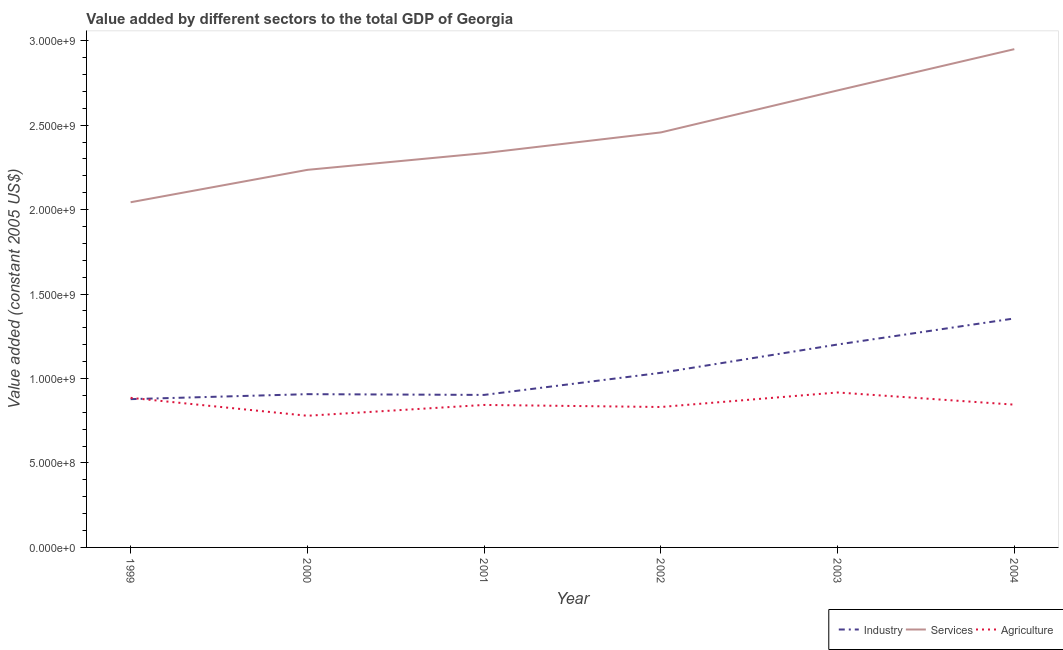How many different coloured lines are there?
Your answer should be very brief. 3. Does the line corresponding to value added by services intersect with the line corresponding to value added by industrial sector?
Offer a very short reply. No. Is the number of lines equal to the number of legend labels?
Provide a succinct answer. Yes. What is the value added by services in 2003?
Ensure brevity in your answer.  2.71e+09. Across all years, what is the maximum value added by services?
Keep it short and to the point. 2.95e+09. Across all years, what is the minimum value added by industrial sector?
Offer a very short reply. 8.78e+08. In which year was the value added by services maximum?
Provide a short and direct response. 2004. What is the total value added by industrial sector in the graph?
Keep it short and to the point. 6.28e+09. What is the difference between the value added by industrial sector in 2001 and that in 2004?
Offer a terse response. -4.53e+08. What is the difference between the value added by industrial sector in 1999 and the value added by agricultural sector in 2004?
Keep it short and to the point. 3.27e+07. What is the average value added by services per year?
Give a very brief answer. 2.45e+09. In the year 2003, what is the difference between the value added by industrial sector and value added by services?
Your response must be concise. -1.50e+09. What is the ratio of the value added by industrial sector in 2001 to that in 2004?
Ensure brevity in your answer.  0.67. What is the difference between the highest and the second highest value added by industrial sector?
Your answer should be very brief. 1.54e+08. What is the difference between the highest and the lowest value added by services?
Your answer should be compact. 9.06e+08. In how many years, is the value added by services greater than the average value added by services taken over all years?
Offer a terse response. 3. Is the sum of the value added by industrial sector in 2001 and 2003 greater than the maximum value added by agricultural sector across all years?
Provide a short and direct response. Yes. Is it the case that in every year, the sum of the value added by industrial sector and value added by services is greater than the value added by agricultural sector?
Offer a very short reply. Yes. Is the value added by agricultural sector strictly less than the value added by services over the years?
Offer a terse response. Yes. How many lines are there?
Give a very brief answer. 3. What is the difference between two consecutive major ticks on the Y-axis?
Give a very brief answer. 5.00e+08. Does the graph contain grids?
Offer a terse response. No. Where does the legend appear in the graph?
Provide a short and direct response. Bottom right. What is the title of the graph?
Offer a very short reply. Value added by different sectors to the total GDP of Georgia. Does "Manufactures" appear as one of the legend labels in the graph?
Ensure brevity in your answer.  No. What is the label or title of the Y-axis?
Ensure brevity in your answer.  Value added (constant 2005 US$). What is the Value added (constant 2005 US$) in Industry in 1999?
Offer a very short reply. 8.78e+08. What is the Value added (constant 2005 US$) of Services in 1999?
Keep it short and to the point. 2.04e+09. What is the Value added (constant 2005 US$) of Agriculture in 1999?
Keep it short and to the point. 8.86e+08. What is the Value added (constant 2005 US$) of Industry in 2000?
Make the answer very short. 9.07e+08. What is the Value added (constant 2005 US$) in Services in 2000?
Ensure brevity in your answer.  2.24e+09. What is the Value added (constant 2005 US$) of Agriculture in 2000?
Keep it short and to the point. 7.80e+08. What is the Value added (constant 2005 US$) of Industry in 2001?
Provide a short and direct response. 9.03e+08. What is the Value added (constant 2005 US$) of Services in 2001?
Offer a terse response. 2.33e+09. What is the Value added (constant 2005 US$) of Agriculture in 2001?
Give a very brief answer. 8.44e+08. What is the Value added (constant 2005 US$) in Industry in 2002?
Provide a succinct answer. 1.03e+09. What is the Value added (constant 2005 US$) of Services in 2002?
Offer a terse response. 2.46e+09. What is the Value added (constant 2005 US$) of Agriculture in 2002?
Keep it short and to the point. 8.31e+08. What is the Value added (constant 2005 US$) in Industry in 2003?
Ensure brevity in your answer.  1.20e+09. What is the Value added (constant 2005 US$) of Services in 2003?
Offer a terse response. 2.71e+09. What is the Value added (constant 2005 US$) of Agriculture in 2003?
Keep it short and to the point. 9.17e+08. What is the Value added (constant 2005 US$) of Industry in 2004?
Your answer should be very brief. 1.36e+09. What is the Value added (constant 2005 US$) of Services in 2004?
Offer a very short reply. 2.95e+09. What is the Value added (constant 2005 US$) of Agriculture in 2004?
Ensure brevity in your answer.  8.45e+08. Across all years, what is the maximum Value added (constant 2005 US$) of Industry?
Offer a terse response. 1.36e+09. Across all years, what is the maximum Value added (constant 2005 US$) in Services?
Your response must be concise. 2.95e+09. Across all years, what is the maximum Value added (constant 2005 US$) of Agriculture?
Provide a short and direct response. 9.17e+08. Across all years, what is the minimum Value added (constant 2005 US$) of Industry?
Offer a very short reply. 8.78e+08. Across all years, what is the minimum Value added (constant 2005 US$) in Services?
Keep it short and to the point. 2.04e+09. Across all years, what is the minimum Value added (constant 2005 US$) of Agriculture?
Your response must be concise. 7.80e+08. What is the total Value added (constant 2005 US$) of Industry in the graph?
Your response must be concise. 6.28e+09. What is the total Value added (constant 2005 US$) of Services in the graph?
Keep it short and to the point. 1.47e+1. What is the total Value added (constant 2005 US$) of Agriculture in the graph?
Keep it short and to the point. 5.10e+09. What is the difference between the Value added (constant 2005 US$) of Industry in 1999 and that in 2000?
Provide a short and direct response. -2.95e+07. What is the difference between the Value added (constant 2005 US$) in Services in 1999 and that in 2000?
Provide a short and direct response. -1.92e+08. What is the difference between the Value added (constant 2005 US$) in Agriculture in 1999 and that in 2000?
Offer a very short reply. 1.06e+08. What is the difference between the Value added (constant 2005 US$) of Industry in 1999 and that in 2001?
Make the answer very short. -2.50e+07. What is the difference between the Value added (constant 2005 US$) in Services in 1999 and that in 2001?
Provide a short and direct response. -2.91e+08. What is the difference between the Value added (constant 2005 US$) in Agriculture in 1999 and that in 2001?
Your response must be concise. 4.20e+07. What is the difference between the Value added (constant 2005 US$) of Industry in 1999 and that in 2002?
Offer a very short reply. -1.56e+08. What is the difference between the Value added (constant 2005 US$) in Services in 1999 and that in 2002?
Provide a succinct answer. -4.13e+08. What is the difference between the Value added (constant 2005 US$) in Agriculture in 1999 and that in 2002?
Offer a terse response. 5.42e+07. What is the difference between the Value added (constant 2005 US$) in Industry in 1999 and that in 2003?
Make the answer very short. -3.23e+08. What is the difference between the Value added (constant 2005 US$) of Services in 1999 and that in 2003?
Offer a terse response. -6.62e+08. What is the difference between the Value added (constant 2005 US$) of Agriculture in 1999 and that in 2003?
Offer a terse response. -3.18e+07. What is the difference between the Value added (constant 2005 US$) of Industry in 1999 and that in 2004?
Ensure brevity in your answer.  -4.78e+08. What is the difference between the Value added (constant 2005 US$) in Services in 1999 and that in 2004?
Give a very brief answer. -9.06e+08. What is the difference between the Value added (constant 2005 US$) of Agriculture in 1999 and that in 2004?
Your response must be concise. 4.04e+07. What is the difference between the Value added (constant 2005 US$) in Industry in 2000 and that in 2001?
Provide a short and direct response. 4.43e+06. What is the difference between the Value added (constant 2005 US$) in Services in 2000 and that in 2001?
Offer a terse response. -9.90e+07. What is the difference between the Value added (constant 2005 US$) in Agriculture in 2000 and that in 2001?
Provide a short and direct response. -6.40e+07. What is the difference between the Value added (constant 2005 US$) of Industry in 2000 and that in 2002?
Give a very brief answer. -1.26e+08. What is the difference between the Value added (constant 2005 US$) of Services in 2000 and that in 2002?
Offer a terse response. -2.22e+08. What is the difference between the Value added (constant 2005 US$) of Agriculture in 2000 and that in 2002?
Provide a short and direct response. -5.19e+07. What is the difference between the Value added (constant 2005 US$) in Industry in 2000 and that in 2003?
Your response must be concise. -2.94e+08. What is the difference between the Value added (constant 2005 US$) of Services in 2000 and that in 2003?
Provide a succinct answer. -4.70e+08. What is the difference between the Value added (constant 2005 US$) in Agriculture in 2000 and that in 2003?
Provide a short and direct response. -1.38e+08. What is the difference between the Value added (constant 2005 US$) in Industry in 2000 and that in 2004?
Provide a short and direct response. -4.48e+08. What is the difference between the Value added (constant 2005 US$) of Services in 2000 and that in 2004?
Your response must be concise. -7.15e+08. What is the difference between the Value added (constant 2005 US$) of Agriculture in 2000 and that in 2004?
Offer a very short reply. -6.57e+07. What is the difference between the Value added (constant 2005 US$) of Industry in 2001 and that in 2002?
Ensure brevity in your answer.  -1.31e+08. What is the difference between the Value added (constant 2005 US$) of Services in 2001 and that in 2002?
Ensure brevity in your answer.  -1.23e+08. What is the difference between the Value added (constant 2005 US$) of Agriculture in 2001 and that in 2002?
Your response must be concise. 1.22e+07. What is the difference between the Value added (constant 2005 US$) of Industry in 2001 and that in 2003?
Your answer should be compact. -2.98e+08. What is the difference between the Value added (constant 2005 US$) of Services in 2001 and that in 2003?
Your answer should be compact. -3.71e+08. What is the difference between the Value added (constant 2005 US$) of Agriculture in 2001 and that in 2003?
Provide a short and direct response. -7.38e+07. What is the difference between the Value added (constant 2005 US$) of Industry in 2001 and that in 2004?
Provide a short and direct response. -4.53e+08. What is the difference between the Value added (constant 2005 US$) of Services in 2001 and that in 2004?
Offer a very short reply. -6.16e+08. What is the difference between the Value added (constant 2005 US$) in Agriculture in 2001 and that in 2004?
Provide a succinct answer. -1.68e+06. What is the difference between the Value added (constant 2005 US$) in Industry in 2002 and that in 2003?
Offer a terse response. -1.68e+08. What is the difference between the Value added (constant 2005 US$) of Services in 2002 and that in 2003?
Offer a very short reply. -2.49e+08. What is the difference between the Value added (constant 2005 US$) in Agriculture in 2002 and that in 2003?
Offer a very short reply. -8.60e+07. What is the difference between the Value added (constant 2005 US$) of Industry in 2002 and that in 2004?
Provide a short and direct response. -3.22e+08. What is the difference between the Value added (constant 2005 US$) of Services in 2002 and that in 2004?
Give a very brief answer. -4.93e+08. What is the difference between the Value added (constant 2005 US$) of Agriculture in 2002 and that in 2004?
Offer a terse response. -1.39e+07. What is the difference between the Value added (constant 2005 US$) of Industry in 2003 and that in 2004?
Offer a very short reply. -1.54e+08. What is the difference between the Value added (constant 2005 US$) in Services in 2003 and that in 2004?
Your answer should be compact. -2.44e+08. What is the difference between the Value added (constant 2005 US$) of Agriculture in 2003 and that in 2004?
Ensure brevity in your answer.  7.21e+07. What is the difference between the Value added (constant 2005 US$) in Industry in 1999 and the Value added (constant 2005 US$) in Services in 2000?
Your answer should be compact. -1.36e+09. What is the difference between the Value added (constant 2005 US$) of Industry in 1999 and the Value added (constant 2005 US$) of Agriculture in 2000?
Offer a terse response. 9.84e+07. What is the difference between the Value added (constant 2005 US$) in Services in 1999 and the Value added (constant 2005 US$) in Agriculture in 2000?
Keep it short and to the point. 1.26e+09. What is the difference between the Value added (constant 2005 US$) in Industry in 1999 and the Value added (constant 2005 US$) in Services in 2001?
Provide a succinct answer. -1.46e+09. What is the difference between the Value added (constant 2005 US$) of Industry in 1999 and the Value added (constant 2005 US$) of Agriculture in 2001?
Offer a very short reply. 3.43e+07. What is the difference between the Value added (constant 2005 US$) in Services in 1999 and the Value added (constant 2005 US$) in Agriculture in 2001?
Your answer should be very brief. 1.20e+09. What is the difference between the Value added (constant 2005 US$) in Industry in 1999 and the Value added (constant 2005 US$) in Services in 2002?
Keep it short and to the point. -1.58e+09. What is the difference between the Value added (constant 2005 US$) in Industry in 1999 and the Value added (constant 2005 US$) in Agriculture in 2002?
Your answer should be very brief. 4.65e+07. What is the difference between the Value added (constant 2005 US$) of Services in 1999 and the Value added (constant 2005 US$) of Agriculture in 2002?
Keep it short and to the point. 1.21e+09. What is the difference between the Value added (constant 2005 US$) in Industry in 1999 and the Value added (constant 2005 US$) in Services in 2003?
Provide a succinct answer. -1.83e+09. What is the difference between the Value added (constant 2005 US$) in Industry in 1999 and the Value added (constant 2005 US$) in Agriculture in 2003?
Offer a very short reply. -3.95e+07. What is the difference between the Value added (constant 2005 US$) of Services in 1999 and the Value added (constant 2005 US$) of Agriculture in 2003?
Provide a succinct answer. 1.13e+09. What is the difference between the Value added (constant 2005 US$) of Industry in 1999 and the Value added (constant 2005 US$) of Services in 2004?
Offer a terse response. -2.07e+09. What is the difference between the Value added (constant 2005 US$) in Industry in 1999 and the Value added (constant 2005 US$) in Agriculture in 2004?
Your response must be concise. 3.27e+07. What is the difference between the Value added (constant 2005 US$) in Services in 1999 and the Value added (constant 2005 US$) in Agriculture in 2004?
Your answer should be compact. 1.20e+09. What is the difference between the Value added (constant 2005 US$) of Industry in 2000 and the Value added (constant 2005 US$) of Services in 2001?
Your answer should be very brief. -1.43e+09. What is the difference between the Value added (constant 2005 US$) of Industry in 2000 and the Value added (constant 2005 US$) of Agriculture in 2001?
Your response must be concise. 6.38e+07. What is the difference between the Value added (constant 2005 US$) of Services in 2000 and the Value added (constant 2005 US$) of Agriculture in 2001?
Offer a very short reply. 1.39e+09. What is the difference between the Value added (constant 2005 US$) in Industry in 2000 and the Value added (constant 2005 US$) in Services in 2002?
Offer a terse response. -1.55e+09. What is the difference between the Value added (constant 2005 US$) in Industry in 2000 and the Value added (constant 2005 US$) in Agriculture in 2002?
Your answer should be compact. 7.60e+07. What is the difference between the Value added (constant 2005 US$) in Services in 2000 and the Value added (constant 2005 US$) in Agriculture in 2002?
Keep it short and to the point. 1.40e+09. What is the difference between the Value added (constant 2005 US$) in Industry in 2000 and the Value added (constant 2005 US$) in Services in 2003?
Keep it short and to the point. -1.80e+09. What is the difference between the Value added (constant 2005 US$) of Industry in 2000 and the Value added (constant 2005 US$) of Agriculture in 2003?
Offer a terse response. -1.00e+07. What is the difference between the Value added (constant 2005 US$) of Services in 2000 and the Value added (constant 2005 US$) of Agriculture in 2003?
Your answer should be very brief. 1.32e+09. What is the difference between the Value added (constant 2005 US$) of Industry in 2000 and the Value added (constant 2005 US$) of Services in 2004?
Provide a succinct answer. -2.04e+09. What is the difference between the Value added (constant 2005 US$) of Industry in 2000 and the Value added (constant 2005 US$) of Agriculture in 2004?
Offer a terse response. 6.21e+07. What is the difference between the Value added (constant 2005 US$) of Services in 2000 and the Value added (constant 2005 US$) of Agriculture in 2004?
Offer a terse response. 1.39e+09. What is the difference between the Value added (constant 2005 US$) of Industry in 2001 and the Value added (constant 2005 US$) of Services in 2002?
Your answer should be compact. -1.55e+09. What is the difference between the Value added (constant 2005 US$) in Industry in 2001 and the Value added (constant 2005 US$) in Agriculture in 2002?
Offer a very short reply. 7.16e+07. What is the difference between the Value added (constant 2005 US$) of Services in 2001 and the Value added (constant 2005 US$) of Agriculture in 2002?
Offer a very short reply. 1.50e+09. What is the difference between the Value added (constant 2005 US$) of Industry in 2001 and the Value added (constant 2005 US$) of Services in 2003?
Offer a terse response. -1.80e+09. What is the difference between the Value added (constant 2005 US$) of Industry in 2001 and the Value added (constant 2005 US$) of Agriculture in 2003?
Provide a short and direct response. -1.44e+07. What is the difference between the Value added (constant 2005 US$) in Services in 2001 and the Value added (constant 2005 US$) in Agriculture in 2003?
Offer a very short reply. 1.42e+09. What is the difference between the Value added (constant 2005 US$) in Industry in 2001 and the Value added (constant 2005 US$) in Services in 2004?
Your answer should be compact. -2.05e+09. What is the difference between the Value added (constant 2005 US$) of Industry in 2001 and the Value added (constant 2005 US$) of Agriculture in 2004?
Your answer should be very brief. 5.77e+07. What is the difference between the Value added (constant 2005 US$) of Services in 2001 and the Value added (constant 2005 US$) of Agriculture in 2004?
Provide a succinct answer. 1.49e+09. What is the difference between the Value added (constant 2005 US$) of Industry in 2002 and the Value added (constant 2005 US$) of Services in 2003?
Your response must be concise. -1.67e+09. What is the difference between the Value added (constant 2005 US$) of Industry in 2002 and the Value added (constant 2005 US$) of Agriculture in 2003?
Your answer should be very brief. 1.16e+08. What is the difference between the Value added (constant 2005 US$) of Services in 2002 and the Value added (constant 2005 US$) of Agriculture in 2003?
Offer a very short reply. 1.54e+09. What is the difference between the Value added (constant 2005 US$) in Industry in 2002 and the Value added (constant 2005 US$) in Services in 2004?
Give a very brief answer. -1.92e+09. What is the difference between the Value added (constant 2005 US$) in Industry in 2002 and the Value added (constant 2005 US$) in Agriculture in 2004?
Your answer should be compact. 1.88e+08. What is the difference between the Value added (constant 2005 US$) in Services in 2002 and the Value added (constant 2005 US$) in Agriculture in 2004?
Make the answer very short. 1.61e+09. What is the difference between the Value added (constant 2005 US$) in Industry in 2003 and the Value added (constant 2005 US$) in Services in 2004?
Provide a succinct answer. -1.75e+09. What is the difference between the Value added (constant 2005 US$) in Industry in 2003 and the Value added (constant 2005 US$) in Agriculture in 2004?
Give a very brief answer. 3.56e+08. What is the difference between the Value added (constant 2005 US$) of Services in 2003 and the Value added (constant 2005 US$) of Agriculture in 2004?
Your answer should be compact. 1.86e+09. What is the average Value added (constant 2005 US$) in Industry per year?
Keep it short and to the point. 1.05e+09. What is the average Value added (constant 2005 US$) in Services per year?
Offer a very short reply. 2.45e+09. What is the average Value added (constant 2005 US$) in Agriculture per year?
Offer a very short reply. 8.51e+08. In the year 1999, what is the difference between the Value added (constant 2005 US$) of Industry and Value added (constant 2005 US$) of Services?
Provide a short and direct response. -1.17e+09. In the year 1999, what is the difference between the Value added (constant 2005 US$) in Industry and Value added (constant 2005 US$) in Agriculture?
Make the answer very short. -7.70e+06. In the year 1999, what is the difference between the Value added (constant 2005 US$) in Services and Value added (constant 2005 US$) in Agriculture?
Make the answer very short. 1.16e+09. In the year 2000, what is the difference between the Value added (constant 2005 US$) of Industry and Value added (constant 2005 US$) of Services?
Keep it short and to the point. -1.33e+09. In the year 2000, what is the difference between the Value added (constant 2005 US$) of Industry and Value added (constant 2005 US$) of Agriculture?
Keep it short and to the point. 1.28e+08. In the year 2000, what is the difference between the Value added (constant 2005 US$) in Services and Value added (constant 2005 US$) in Agriculture?
Provide a short and direct response. 1.46e+09. In the year 2001, what is the difference between the Value added (constant 2005 US$) in Industry and Value added (constant 2005 US$) in Services?
Ensure brevity in your answer.  -1.43e+09. In the year 2001, what is the difference between the Value added (constant 2005 US$) in Industry and Value added (constant 2005 US$) in Agriculture?
Your response must be concise. 5.94e+07. In the year 2001, what is the difference between the Value added (constant 2005 US$) of Services and Value added (constant 2005 US$) of Agriculture?
Keep it short and to the point. 1.49e+09. In the year 2002, what is the difference between the Value added (constant 2005 US$) of Industry and Value added (constant 2005 US$) of Services?
Provide a succinct answer. -1.42e+09. In the year 2002, what is the difference between the Value added (constant 2005 US$) in Industry and Value added (constant 2005 US$) in Agriculture?
Provide a succinct answer. 2.02e+08. In the year 2002, what is the difference between the Value added (constant 2005 US$) of Services and Value added (constant 2005 US$) of Agriculture?
Your answer should be very brief. 1.63e+09. In the year 2003, what is the difference between the Value added (constant 2005 US$) of Industry and Value added (constant 2005 US$) of Services?
Offer a terse response. -1.50e+09. In the year 2003, what is the difference between the Value added (constant 2005 US$) in Industry and Value added (constant 2005 US$) in Agriculture?
Offer a very short reply. 2.84e+08. In the year 2003, what is the difference between the Value added (constant 2005 US$) in Services and Value added (constant 2005 US$) in Agriculture?
Offer a very short reply. 1.79e+09. In the year 2004, what is the difference between the Value added (constant 2005 US$) in Industry and Value added (constant 2005 US$) in Services?
Make the answer very short. -1.59e+09. In the year 2004, what is the difference between the Value added (constant 2005 US$) of Industry and Value added (constant 2005 US$) of Agriculture?
Your answer should be compact. 5.10e+08. In the year 2004, what is the difference between the Value added (constant 2005 US$) of Services and Value added (constant 2005 US$) of Agriculture?
Ensure brevity in your answer.  2.10e+09. What is the ratio of the Value added (constant 2005 US$) of Industry in 1999 to that in 2000?
Your answer should be compact. 0.97. What is the ratio of the Value added (constant 2005 US$) of Services in 1999 to that in 2000?
Your answer should be compact. 0.91. What is the ratio of the Value added (constant 2005 US$) of Agriculture in 1999 to that in 2000?
Your answer should be compact. 1.14. What is the ratio of the Value added (constant 2005 US$) in Industry in 1999 to that in 2001?
Keep it short and to the point. 0.97. What is the ratio of the Value added (constant 2005 US$) in Services in 1999 to that in 2001?
Provide a short and direct response. 0.88. What is the ratio of the Value added (constant 2005 US$) in Agriculture in 1999 to that in 2001?
Your response must be concise. 1.05. What is the ratio of the Value added (constant 2005 US$) of Industry in 1999 to that in 2002?
Ensure brevity in your answer.  0.85. What is the ratio of the Value added (constant 2005 US$) in Services in 1999 to that in 2002?
Your answer should be very brief. 0.83. What is the ratio of the Value added (constant 2005 US$) of Agriculture in 1999 to that in 2002?
Your answer should be very brief. 1.07. What is the ratio of the Value added (constant 2005 US$) of Industry in 1999 to that in 2003?
Provide a succinct answer. 0.73. What is the ratio of the Value added (constant 2005 US$) of Services in 1999 to that in 2003?
Keep it short and to the point. 0.76. What is the ratio of the Value added (constant 2005 US$) in Agriculture in 1999 to that in 2003?
Your response must be concise. 0.97. What is the ratio of the Value added (constant 2005 US$) of Industry in 1999 to that in 2004?
Offer a terse response. 0.65. What is the ratio of the Value added (constant 2005 US$) of Services in 1999 to that in 2004?
Keep it short and to the point. 0.69. What is the ratio of the Value added (constant 2005 US$) of Agriculture in 1999 to that in 2004?
Offer a very short reply. 1.05. What is the ratio of the Value added (constant 2005 US$) of Services in 2000 to that in 2001?
Ensure brevity in your answer.  0.96. What is the ratio of the Value added (constant 2005 US$) in Agriculture in 2000 to that in 2001?
Your answer should be very brief. 0.92. What is the ratio of the Value added (constant 2005 US$) in Industry in 2000 to that in 2002?
Offer a very short reply. 0.88. What is the ratio of the Value added (constant 2005 US$) of Services in 2000 to that in 2002?
Offer a terse response. 0.91. What is the ratio of the Value added (constant 2005 US$) of Agriculture in 2000 to that in 2002?
Your answer should be compact. 0.94. What is the ratio of the Value added (constant 2005 US$) in Industry in 2000 to that in 2003?
Your answer should be compact. 0.76. What is the ratio of the Value added (constant 2005 US$) in Services in 2000 to that in 2003?
Your answer should be very brief. 0.83. What is the ratio of the Value added (constant 2005 US$) in Agriculture in 2000 to that in 2003?
Keep it short and to the point. 0.85. What is the ratio of the Value added (constant 2005 US$) of Industry in 2000 to that in 2004?
Offer a terse response. 0.67. What is the ratio of the Value added (constant 2005 US$) in Services in 2000 to that in 2004?
Provide a succinct answer. 0.76. What is the ratio of the Value added (constant 2005 US$) of Agriculture in 2000 to that in 2004?
Provide a succinct answer. 0.92. What is the ratio of the Value added (constant 2005 US$) of Industry in 2001 to that in 2002?
Give a very brief answer. 0.87. What is the ratio of the Value added (constant 2005 US$) in Services in 2001 to that in 2002?
Your response must be concise. 0.95. What is the ratio of the Value added (constant 2005 US$) of Agriculture in 2001 to that in 2002?
Offer a terse response. 1.01. What is the ratio of the Value added (constant 2005 US$) in Industry in 2001 to that in 2003?
Your response must be concise. 0.75. What is the ratio of the Value added (constant 2005 US$) of Services in 2001 to that in 2003?
Provide a short and direct response. 0.86. What is the ratio of the Value added (constant 2005 US$) of Agriculture in 2001 to that in 2003?
Your answer should be very brief. 0.92. What is the ratio of the Value added (constant 2005 US$) of Industry in 2001 to that in 2004?
Provide a short and direct response. 0.67. What is the ratio of the Value added (constant 2005 US$) of Services in 2001 to that in 2004?
Ensure brevity in your answer.  0.79. What is the ratio of the Value added (constant 2005 US$) in Agriculture in 2001 to that in 2004?
Ensure brevity in your answer.  1. What is the ratio of the Value added (constant 2005 US$) in Industry in 2002 to that in 2003?
Give a very brief answer. 0.86. What is the ratio of the Value added (constant 2005 US$) of Services in 2002 to that in 2003?
Make the answer very short. 0.91. What is the ratio of the Value added (constant 2005 US$) of Agriculture in 2002 to that in 2003?
Offer a very short reply. 0.91. What is the ratio of the Value added (constant 2005 US$) of Industry in 2002 to that in 2004?
Give a very brief answer. 0.76. What is the ratio of the Value added (constant 2005 US$) in Services in 2002 to that in 2004?
Offer a very short reply. 0.83. What is the ratio of the Value added (constant 2005 US$) of Agriculture in 2002 to that in 2004?
Keep it short and to the point. 0.98. What is the ratio of the Value added (constant 2005 US$) in Industry in 2003 to that in 2004?
Keep it short and to the point. 0.89. What is the ratio of the Value added (constant 2005 US$) of Services in 2003 to that in 2004?
Provide a short and direct response. 0.92. What is the ratio of the Value added (constant 2005 US$) in Agriculture in 2003 to that in 2004?
Your answer should be very brief. 1.09. What is the difference between the highest and the second highest Value added (constant 2005 US$) of Industry?
Your answer should be very brief. 1.54e+08. What is the difference between the highest and the second highest Value added (constant 2005 US$) in Services?
Your response must be concise. 2.44e+08. What is the difference between the highest and the second highest Value added (constant 2005 US$) of Agriculture?
Offer a terse response. 3.18e+07. What is the difference between the highest and the lowest Value added (constant 2005 US$) in Industry?
Make the answer very short. 4.78e+08. What is the difference between the highest and the lowest Value added (constant 2005 US$) of Services?
Provide a succinct answer. 9.06e+08. What is the difference between the highest and the lowest Value added (constant 2005 US$) in Agriculture?
Offer a terse response. 1.38e+08. 